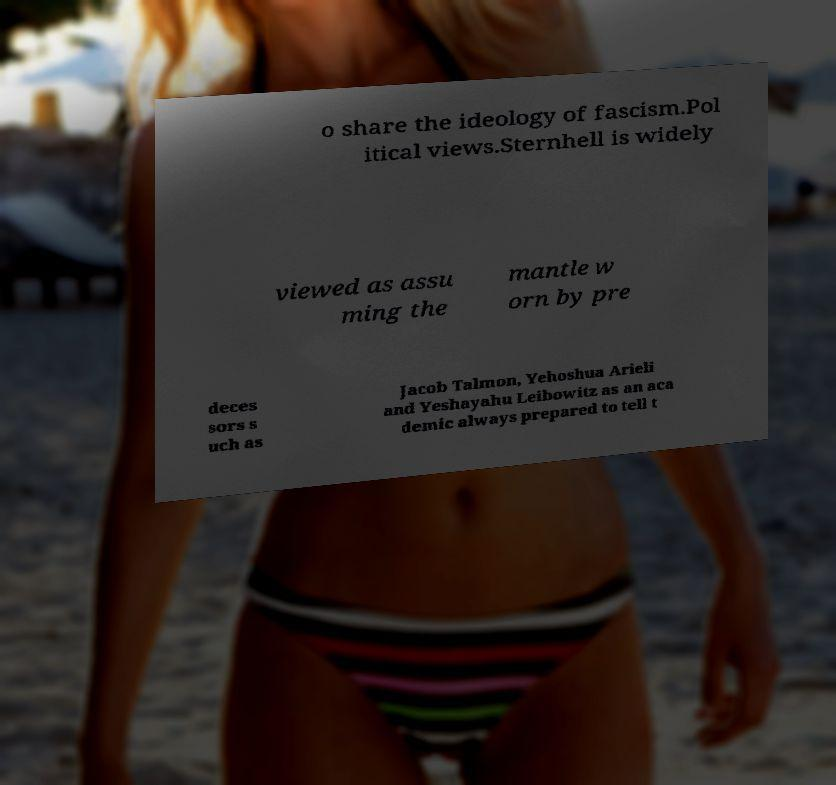Could you assist in decoding the text presented in this image and type it out clearly? o share the ideology of fascism.Pol itical views.Sternhell is widely viewed as assu ming the mantle w orn by pre deces sors s uch as Jacob Talmon, Yehoshua Arieli and Yeshayahu Leibowitz as an aca demic always prepared to tell t 